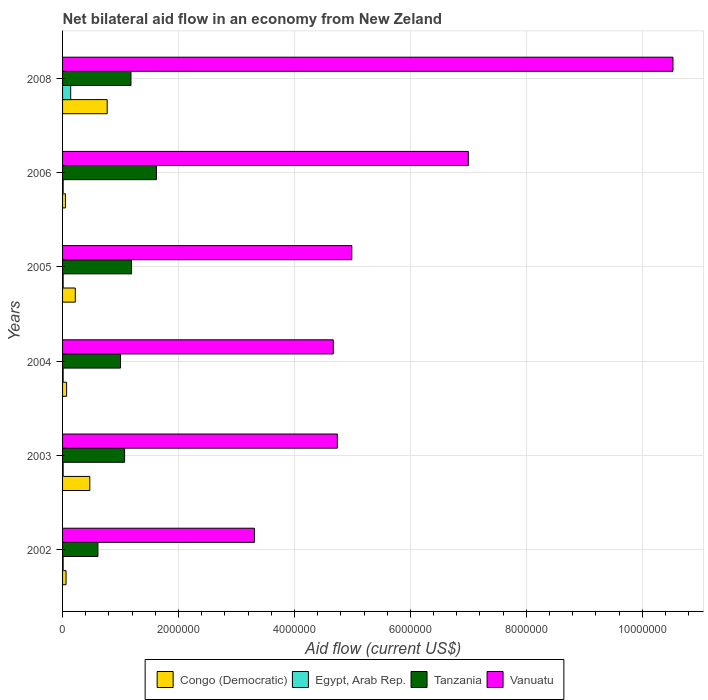How many different coloured bars are there?
Keep it short and to the point. 4. How many groups of bars are there?
Offer a very short reply. 6. Are the number of bars per tick equal to the number of legend labels?
Ensure brevity in your answer.  Yes. Are the number of bars on each tick of the Y-axis equal?
Ensure brevity in your answer.  Yes. How many bars are there on the 3rd tick from the top?
Make the answer very short. 4. How many bars are there on the 4th tick from the bottom?
Your answer should be very brief. 4. What is the label of the 4th group of bars from the top?
Offer a terse response. 2004. In how many cases, is the number of bars for a given year not equal to the number of legend labels?
Your answer should be very brief. 0. Across all years, what is the maximum net bilateral aid flow in Congo (Democratic)?
Your answer should be compact. 7.70e+05. Across all years, what is the minimum net bilateral aid flow in Congo (Democratic)?
Offer a very short reply. 5.00e+04. In which year was the net bilateral aid flow in Vanuatu maximum?
Your answer should be very brief. 2008. In which year was the net bilateral aid flow in Vanuatu minimum?
Give a very brief answer. 2002. What is the total net bilateral aid flow in Egypt, Arab Rep. in the graph?
Keep it short and to the point. 1.90e+05. What is the difference between the net bilateral aid flow in Congo (Democratic) in 2002 and that in 2005?
Provide a short and direct response. -1.60e+05. What is the difference between the net bilateral aid flow in Vanuatu in 2006 and the net bilateral aid flow in Congo (Democratic) in 2003?
Ensure brevity in your answer.  6.53e+06. What is the average net bilateral aid flow in Tanzania per year?
Make the answer very short. 1.11e+06. In the year 2008, what is the difference between the net bilateral aid flow in Vanuatu and net bilateral aid flow in Congo (Democratic)?
Provide a succinct answer. 9.76e+06. In how many years, is the net bilateral aid flow in Tanzania greater than 7600000 US$?
Your answer should be very brief. 0. What is the ratio of the net bilateral aid flow in Tanzania in 2002 to that in 2006?
Provide a short and direct response. 0.38. Is the difference between the net bilateral aid flow in Vanuatu in 2002 and 2004 greater than the difference between the net bilateral aid flow in Congo (Democratic) in 2002 and 2004?
Provide a succinct answer. No. What is the difference between the highest and the lowest net bilateral aid flow in Vanuatu?
Provide a succinct answer. 7.22e+06. In how many years, is the net bilateral aid flow in Congo (Democratic) greater than the average net bilateral aid flow in Congo (Democratic) taken over all years?
Offer a very short reply. 2. Is the sum of the net bilateral aid flow in Egypt, Arab Rep. in 2002 and 2008 greater than the maximum net bilateral aid flow in Vanuatu across all years?
Provide a succinct answer. No. Is it the case that in every year, the sum of the net bilateral aid flow in Congo (Democratic) and net bilateral aid flow in Egypt, Arab Rep. is greater than the sum of net bilateral aid flow in Tanzania and net bilateral aid flow in Vanuatu?
Provide a succinct answer. No. What does the 2nd bar from the top in 2008 represents?
Give a very brief answer. Tanzania. What does the 3rd bar from the bottom in 2003 represents?
Provide a short and direct response. Tanzania. How many years are there in the graph?
Provide a succinct answer. 6. Does the graph contain any zero values?
Offer a very short reply. No. Where does the legend appear in the graph?
Your response must be concise. Bottom center. What is the title of the graph?
Ensure brevity in your answer.  Net bilateral aid flow in an economy from New Zeland. Does "Libya" appear as one of the legend labels in the graph?
Offer a terse response. No. What is the label or title of the X-axis?
Provide a short and direct response. Aid flow (current US$). What is the label or title of the Y-axis?
Provide a short and direct response. Years. What is the Aid flow (current US$) of Congo (Democratic) in 2002?
Provide a succinct answer. 6.00e+04. What is the Aid flow (current US$) in Egypt, Arab Rep. in 2002?
Your response must be concise. 10000. What is the Aid flow (current US$) of Vanuatu in 2002?
Keep it short and to the point. 3.31e+06. What is the Aid flow (current US$) of Congo (Democratic) in 2003?
Offer a very short reply. 4.70e+05. What is the Aid flow (current US$) of Egypt, Arab Rep. in 2003?
Ensure brevity in your answer.  10000. What is the Aid flow (current US$) in Tanzania in 2003?
Your response must be concise. 1.07e+06. What is the Aid flow (current US$) in Vanuatu in 2003?
Keep it short and to the point. 4.74e+06. What is the Aid flow (current US$) in Congo (Democratic) in 2004?
Make the answer very short. 7.00e+04. What is the Aid flow (current US$) in Vanuatu in 2004?
Keep it short and to the point. 4.67e+06. What is the Aid flow (current US$) of Tanzania in 2005?
Give a very brief answer. 1.19e+06. What is the Aid flow (current US$) of Vanuatu in 2005?
Make the answer very short. 4.99e+06. What is the Aid flow (current US$) in Congo (Democratic) in 2006?
Ensure brevity in your answer.  5.00e+04. What is the Aid flow (current US$) of Egypt, Arab Rep. in 2006?
Your response must be concise. 10000. What is the Aid flow (current US$) in Tanzania in 2006?
Your response must be concise. 1.62e+06. What is the Aid flow (current US$) in Vanuatu in 2006?
Offer a very short reply. 7.00e+06. What is the Aid flow (current US$) of Congo (Democratic) in 2008?
Your answer should be very brief. 7.70e+05. What is the Aid flow (current US$) of Tanzania in 2008?
Give a very brief answer. 1.18e+06. What is the Aid flow (current US$) of Vanuatu in 2008?
Ensure brevity in your answer.  1.05e+07. Across all years, what is the maximum Aid flow (current US$) of Congo (Democratic)?
Offer a very short reply. 7.70e+05. Across all years, what is the maximum Aid flow (current US$) of Egypt, Arab Rep.?
Your answer should be compact. 1.40e+05. Across all years, what is the maximum Aid flow (current US$) of Tanzania?
Offer a very short reply. 1.62e+06. Across all years, what is the maximum Aid flow (current US$) of Vanuatu?
Provide a succinct answer. 1.05e+07. Across all years, what is the minimum Aid flow (current US$) in Egypt, Arab Rep.?
Your answer should be very brief. 10000. Across all years, what is the minimum Aid flow (current US$) of Vanuatu?
Keep it short and to the point. 3.31e+06. What is the total Aid flow (current US$) of Congo (Democratic) in the graph?
Offer a terse response. 1.64e+06. What is the total Aid flow (current US$) of Egypt, Arab Rep. in the graph?
Provide a short and direct response. 1.90e+05. What is the total Aid flow (current US$) of Tanzania in the graph?
Your answer should be very brief. 6.67e+06. What is the total Aid flow (current US$) of Vanuatu in the graph?
Your response must be concise. 3.52e+07. What is the difference between the Aid flow (current US$) of Congo (Democratic) in 2002 and that in 2003?
Your answer should be very brief. -4.10e+05. What is the difference between the Aid flow (current US$) in Egypt, Arab Rep. in 2002 and that in 2003?
Give a very brief answer. 0. What is the difference between the Aid flow (current US$) of Tanzania in 2002 and that in 2003?
Offer a terse response. -4.60e+05. What is the difference between the Aid flow (current US$) in Vanuatu in 2002 and that in 2003?
Give a very brief answer. -1.43e+06. What is the difference between the Aid flow (current US$) in Congo (Democratic) in 2002 and that in 2004?
Your response must be concise. -10000. What is the difference between the Aid flow (current US$) in Egypt, Arab Rep. in 2002 and that in 2004?
Ensure brevity in your answer.  0. What is the difference between the Aid flow (current US$) of Tanzania in 2002 and that in 2004?
Offer a terse response. -3.90e+05. What is the difference between the Aid flow (current US$) of Vanuatu in 2002 and that in 2004?
Provide a short and direct response. -1.36e+06. What is the difference between the Aid flow (current US$) of Tanzania in 2002 and that in 2005?
Your answer should be compact. -5.80e+05. What is the difference between the Aid flow (current US$) in Vanuatu in 2002 and that in 2005?
Provide a succinct answer. -1.68e+06. What is the difference between the Aid flow (current US$) of Egypt, Arab Rep. in 2002 and that in 2006?
Offer a terse response. 0. What is the difference between the Aid flow (current US$) in Tanzania in 2002 and that in 2006?
Keep it short and to the point. -1.01e+06. What is the difference between the Aid flow (current US$) of Vanuatu in 2002 and that in 2006?
Offer a very short reply. -3.69e+06. What is the difference between the Aid flow (current US$) of Congo (Democratic) in 2002 and that in 2008?
Give a very brief answer. -7.10e+05. What is the difference between the Aid flow (current US$) of Tanzania in 2002 and that in 2008?
Your response must be concise. -5.70e+05. What is the difference between the Aid flow (current US$) in Vanuatu in 2002 and that in 2008?
Ensure brevity in your answer.  -7.22e+06. What is the difference between the Aid flow (current US$) of Congo (Democratic) in 2003 and that in 2004?
Make the answer very short. 4.00e+05. What is the difference between the Aid flow (current US$) in Egypt, Arab Rep. in 2003 and that in 2004?
Keep it short and to the point. 0. What is the difference between the Aid flow (current US$) in Tanzania in 2003 and that in 2004?
Make the answer very short. 7.00e+04. What is the difference between the Aid flow (current US$) in Egypt, Arab Rep. in 2003 and that in 2005?
Your answer should be compact. 0. What is the difference between the Aid flow (current US$) in Tanzania in 2003 and that in 2005?
Provide a succinct answer. -1.20e+05. What is the difference between the Aid flow (current US$) in Egypt, Arab Rep. in 2003 and that in 2006?
Offer a terse response. 0. What is the difference between the Aid flow (current US$) in Tanzania in 2003 and that in 2006?
Keep it short and to the point. -5.50e+05. What is the difference between the Aid flow (current US$) in Vanuatu in 2003 and that in 2006?
Your response must be concise. -2.26e+06. What is the difference between the Aid flow (current US$) of Tanzania in 2003 and that in 2008?
Make the answer very short. -1.10e+05. What is the difference between the Aid flow (current US$) in Vanuatu in 2003 and that in 2008?
Keep it short and to the point. -5.79e+06. What is the difference between the Aid flow (current US$) in Congo (Democratic) in 2004 and that in 2005?
Offer a terse response. -1.50e+05. What is the difference between the Aid flow (current US$) of Vanuatu in 2004 and that in 2005?
Provide a succinct answer. -3.20e+05. What is the difference between the Aid flow (current US$) in Congo (Democratic) in 2004 and that in 2006?
Make the answer very short. 2.00e+04. What is the difference between the Aid flow (current US$) in Tanzania in 2004 and that in 2006?
Offer a very short reply. -6.20e+05. What is the difference between the Aid flow (current US$) of Vanuatu in 2004 and that in 2006?
Give a very brief answer. -2.33e+06. What is the difference between the Aid flow (current US$) in Congo (Democratic) in 2004 and that in 2008?
Offer a terse response. -7.00e+05. What is the difference between the Aid flow (current US$) of Tanzania in 2004 and that in 2008?
Offer a terse response. -1.80e+05. What is the difference between the Aid flow (current US$) in Vanuatu in 2004 and that in 2008?
Provide a succinct answer. -5.86e+06. What is the difference between the Aid flow (current US$) of Tanzania in 2005 and that in 2006?
Provide a short and direct response. -4.30e+05. What is the difference between the Aid flow (current US$) of Vanuatu in 2005 and that in 2006?
Offer a very short reply. -2.01e+06. What is the difference between the Aid flow (current US$) of Congo (Democratic) in 2005 and that in 2008?
Provide a short and direct response. -5.50e+05. What is the difference between the Aid flow (current US$) in Vanuatu in 2005 and that in 2008?
Provide a short and direct response. -5.54e+06. What is the difference between the Aid flow (current US$) in Congo (Democratic) in 2006 and that in 2008?
Ensure brevity in your answer.  -7.20e+05. What is the difference between the Aid flow (current US$) of Egypt, Arab Rep. in 2006 and that in 2008?
Offer a very short reply. -1.30e+05. What is the difference between the Aid flow (current US$) in Vanuatu in 2006 and that in 2008?
Make the answer very short. -3.53e+06. What is the difference between the Aid flow (current US$) in Congo (Democratic) in 2002 and the Aid flow (current US$) in Tanzania in 2003?
Your response must be concise. -1.01e+06. What is the difference between the Aid flow (current US$) in Congo (Democratic) in 2002 and the Aid flow (current US$) in Vanuatu in 2003?
Offer a terse response. -4.68e+06. What is the difference between the Aid flow (current US$) of Egypt, Arab Rep. in 2002 and the Aid flow (current US$) of Tanzania in 2003?
Offer a very short reply. -1.06e+06. What is the difference between the Aid flow (current US$) of Egypt, Arab Rep. in 2002 and the Aid flow (current US$) of Vanuatu in 2003?
Keep it short and to the point. -4.73e+06. What is the difference between the Aid flow (current US$) in Tanzania in 2002 and the Aid flow (current US$) in Vanuatu in 2003?
Offer a very short reply. -4.13e+06. What is the difference between the Aid flow (current US$) of Congo (Democratic) in 2002 and the Aid flow (current US$) of Egypt, Arab Rep. in 2004?
Provide a succinct answer. 5.00e+04. What is the difference between the Aid flow (current US$) of Congo (Democratic) in 2002 and the Aid flow (current US$) of Tanzania in 2004?
Your answer should be very brief. -9.40e+05. What is the difference between the Aid flow (current US$) of Congo (Democratic) in 2002 and the Aid flow (current US$) of Vanuatu in 2004?
Keep it short and to the point. -4.61e+06. What is the difference between the Aid flow (current US$) of Egypt, Arab Rep. in 2002 and the Aid flow (current US$) of Tanzania in 2004?
Keep it short and to the point. -9.90e+05. What is the difference between the Aid flow (current US$) of Egypt, Arab Rep. in 2002 and the Aid flow (current US$) of Vanuatu in 2004?
Offer a very short reply. -4.66e+06. What is the difference between the Aid flow (current US$) in Tanzania in 2002 and the Aid flow (current US$) in Vanuatu in 2004?
Provide a succinct answer. -4.06e+06. What is the difference between the Aid flow (current US$) in Congo (Democratic) in 2002 and the Aid flow (current US$) in Tanzania in 2005?
Keep it short and to the point. -1.13e+06. What is the difference between the Aid flow (current US$) in Congo (Democratic) in 2002 and the Aid flow (current US$) in Vanuatu in 2005?
Ensure brevity in your answer.  -4.93e+06. What is the difference between the Aid flow (current US$) in Egypt, Arab Rep. in 2002 and the Aid flow (current US$) in Tanzania in 2005?
Make the answer very short. -1.18e+06. What is the difference between the Aid flow (current US$) in Egypt, Arab Rep. in 2002 and the Aid flow (current US$) in Vanuatu in 2005?
Your answer should be very brief. -4.98e+06. What is the difference between the Aid flow (current US$) in Tanzania in 2002 and the Aid flow (current US$) in Vanuatu in 2005?
Your answer should be compact. -4.38e+06. What is the difference between the Aid flow (current US$) of Congo (Democratic) in 2002 and the Aid flow (current US$) of Tanzania in 2006?
Provide a short and direct response. -1.56e+06. What is the difference between the Aid flow (current US$) in Congo (Democratic) in 2002 and the Aid flow (current US$) in Vanuatu in 2006?
Offer a terse response. -6.94e+06. What is the difference between the Aid flow (current US$) in Egypt, Arab Rep. in 2002 and the Aid flow (current US$) in Tanzania in 2006?
Provide a short and direct response. -1.61e+06. What is the difference between the Aid flow (current US$) in Egypt, Arab Rep. in 2002 and the Aid flow (current US$) in Vanuatu in 2006?
Make the answer very short. -6.99e+06. What is the difference between the Aid flow (current US$) in Tanzania in 2002 and the Aid flow (current US$) in Vanuatu in 2006?
Provide a short and direct response. -6.39e+06. What is the difference between the Aid flow (current US$) of Congo (Democratic) in 2002 and the Aid flow (current US$) of Tanzania in 2008?
Your answer should be very brief. -1.12e+06. What is the difference between the Aid flow (current US$) of Congo (Democratic) in 2002 and the Aid flow (current US$) of Vanuatu in 2008?
Provide a succinct answer. -1.05e+07. What is the difference between the Aid flow (current US$) in Egypt, Arab Rep. in 2002 and the Aid flow (current US$) in Tanzania in 2008?
Make the answer very short. -1.17e+06. What is the difference between the Aid flow (current US$) of Egypt, Arab Rep. in 2002 and the Aid flow (current US$) of Vanuatu in 2008?
Keep it short and to the point. -1.05e+07. What is the difference between the Aid flow (current US$) of Tanzania in 2002 and the Aid flow (current US$) of Vanuatu in 2008?
Give a very brief answer. -9.92e+06. What is the difference between the Aid flow (current US$) of Congo (Democratic) in 2003 and the Aid flow (current US$) of Tanzania in 2004?
Provide a succinct answer. -5.30e+05. What is the difference between the Aid flow (current US$) of Congo (Democratic) in 2003 and the Aid flow (current US$) of Vanuatu in 2004?
Give a very brief answer. -4.20e+06. What is the difference between the Aid flow (current US$) of Egypt, Arab Rep. in 2003 and the Aid flow (current US$) of Tanzania in 2004?
Offer a terse response. -9.90e+05. What is the difference between the Aid flow (current US$) of Egypt, Arab Rep. in 2003 and the Aid flow (current US$) of Vanuatu in 2004?
Make the answer very short. -4.66e+06. What is the difference between the Aid flow (current US$) in Tanzania in 2003 and the Aid flow (current US$) in Vanuatu in 2004?
Offer a terse response. -3.60e+06. What is the difference between the Aid flow (current US$) of Congo (Democratic) in 2003 and the Aid flow (current US$) of Egypt, Arab Rep. in 2005?
Offer a terse response. 4.60e+05. What is the difference between the Aid flow (current US$) in Congo (Democratic) in 2003 and the Aid flow (current US$) in Tanzania in 2005?
Make the answer very short. -7.20e+05. What is the difference between the Aid flow (current US$) in Congo (Democratic) in 2003 and the Aid flow (current US$) in Vanuatu in 2005?
Offer a very short reply. -4.52e+06. What is the difference between the Aid flow (current US$) in Egypt, Arab Rep. in 2003 and the Aid flow (current US$) in Tanzania in 2005?
Keep it short and to the point. -1.18e+06. What is the difference between the Aid flow (current US$) in Egypt, Arab Rep. in 2003 and the Aid flow (current US$) in Vanuatu in 2005?
Keep it short and to the point. -4.98e+06. What is the difference between the Aid flow (current US$) of Tanzania in 2003 and the Aid flow (current US$) of Vanuatu in 2005?
Your answer should be compact. -3.92e+06. What is the difference between the Aid flow (current US$) in Congo (Democratic) in 2003 and the Aid flow (current US$) in Egypt, Arab Rep. in 2006?
Give a very brief answer. 4.60e+05. What is the difference between the Aid flow (current US$) of Congo (Democratic) in 2003 and the Aid flow (current US$) of Tanzania in 2006?
Your answer should be compact. -1.15e+06. What is the difference between the Aid flow (current US$) of Congo (Democratic) in 2003 and the Aid flow (current US$) of Vanuatu in 2006?
Offer a terse response. -6.53e+06. What is the difference between the Aid flow (current US$) in Egypt, Arab Rep. in 2003 and the Aid flow (current US$) in Tanzania in 2006?
Make the answer very short. -1.61e+06. What is the difference between the Aid flow (current US$) of Egypt, Arab Rep. in 2003 and the Aid flow (current US$) of Vanuatu in 2006?
Your answer should be very brief. -6.99e+06. What is the difference between the Aid flow (current US$) in Tanzania in 2003 and the Aid flow (current US$) in Vanuatu in 2006?
Ensure brevity in your answer.  -5.93e+06. What is the difference between the Aid flow (current US$) in Congo (Democratic) in 2003 and the Aid flow (current US$) in Tanzania in 2008?
Your response must be concise. -7.10e+05. What is the difference between the Aid flow (current US$) in Congo (Democratic) in 2003 and the Aid flow (current US$) in Vanuatu in 2008?
Offer a very short reply. -1.01e+07. What is the difference between the Aid flow (current US$) in Egypt, Arab Rep. in 2003 and the Aid flow (current US$) in Tanzania in 2008?
Your answer should be compact. -1.17e+06. What is the difference between the Aid flow (current US$) of Egypt, Arab Rep. in 2003 and the Aid flow (current US$) of Vanuatu in 2008?
Give a very brief answer. -1.05e+07. What is the difference between the Aid flow (current US$) in Tanzania in 2003 and the Aid flow (current US$) in Vanuatu in 2008?
Offer a terse response. -9.46e+06. What is the difference between the Aid flow (current US$) in Congo (Democratic) in 2004 and the Aid flow (current US$) in Tanzania in 2005?
Your response must be concise. -1.12e+06. What is the difference between the Aid flow (current US$) of Congo (Democratic) in 2004 and the Aid flow (current US$) of Vanuatu in 2005?
Make the answer very short. -4.92e+06. What is the difference between the Aid flow (current US$) in Egypt, Arab Rep. in 2004 and the Aid flow (current US$) in Tanzania in 2005?
Your answer should be compact. -1.18e+06. What is the difference between the Aid flow (current US$) in Egypt, Arab Rep. in 2004 and the Aid flow (current US$) in Vanuatu in 2005?
Offer a very short reply. -4.98e+06. What is the difference between the Aid flow (current US$) in Tanzania in 2004 and the Aid flow (current US$) in Vanuatu in 2005?
Provide a short and direct response. -3.99e+06. What is the difference between the Aid flow (current US$) in Congo (Democratic) in 2004 and the Aid flow (current US$) in Tanzania in 2006?
Your answer should be compact. -1.55e+06. What is the difference between the Aid flow (current US$) of Congo (Democratic) in 2004 and the Aid flow (current US$) of Vanuatu in 2006?
Provide a succinct answer. -6.93e+06. What is the difference between the Aid flow (current US$) of Egypt, Arab Rep. in 2004 and the Aid flow (current US$) of Tanzania in 2006?
Provide a short and direct response. -1.61e+06. What is the difference between the Aid flow (current US$) in Egypt, Arab Rep. in 2004 and the Aid flow (current US$) in Vanuatu in 2006?
Your response must be concise. -6.99e+06. What is the difference between the Aid flow (current US$) in Tanzania in 2004 and the Aid flow (current US$) in Vanuatu in 2006?
Keep it short and to the point. -6.00e+06. What is the difference between the Aid flow (current US$) of Congo (Democratic) in 2004 and the Aid flow (current US$) of Tanzania in 2008?
Offer a very short reply. -1.11e+06. What is the difference between the Aid flow (current US$) of Congo (Democratic) in 2004 and the Aid flow (current US$) of Vanuatu in 2008?
Provide a short and direct response. -1.05e+07. What is the difference between the Aid flow (current US$) in Egypt, Arab Rep. in 2004 and the Aid flow (current US$) in Tanzania in 2008?
Provide a short and direct response. -1.17e+06. What is the difference between the Aid flow (current US$) in Egypt, Arab Rep. in 2004 and the Aid flow (current US$) in Vanuatu in 2008?
Give a very brief answer. -1.05e+07. What is the difference between the Aid flow (current US$) in Tanzania in 2004 and the Aid flow (current US$) in Vanuatu in 2008?
Make the answer very short. -9.53e+06. What is the difference between the Aid flow (current US$) in Congo (Democratic) in 2005 and the Aid flow (current US$) in Tanzania in 2006?
Your answer should be compact. -1.40e+06. What is the difference between the Aid flow (current US$) in Congo (Democratic) in 2005 and the Aid flow (current US$) in Vanuatu in 2006?
Offer a terse response. -6.78e+06. What is the difference between the Aid flow (current US$) of Egypt, Arab Rep. in 2005 and the Aid flow (current US$) of Tanzania in 2006?
Your answer should be very brief. -1.61e+06. What is the difference between the Aid flow (current US$) in Egypt, Arab Rep. in 2005 and the Aid flow (current US$) in Vanuatu in 2006?
Keep it short and to the point. -6.99e+06. What is the difference between the Aid flow (current US$) in Tanzania in 2005 and the Aid flow (current US$) in Vanuatu in 2006?
Provide a succinct answer. -5.81e+06. What is the difference between the Aid flow (current US$) of Congo (Democratic) in 2005 and the Aid flow (current US$) of Tanzania in 2008?
Ensure brevity in your answer.  -9.60e+05. What is the difference between the Aid flow (current US$) of Congo (Democratic) in 2005 and the Aid flow (current US$) of Vanuatu in 2008?
Provide a short and direct response. -1.03e+07. What is the difference between the Aid flow (current US$) of Egypt, Arab Rep. in 2005 and the Aid flow (current US$) of Tanzania in 2008?
Give a very brief answer. -1.17e+06. What is the difference between the Aid flow (current US$) in Egypt, Arab Rep. in 2005 and the Aid flow (current US$) in Vanuatu in 2008?
Offer a very short reply. -1.05e+07. What is the difference between the Aid flow (current US$) in Tanzania in 2005 and the Aid flow (current US$) in Vanuatu in 2008?
Keep it short and to the point. -9.34e+06. What is the difference between the Aid flow (current US$) in Congo (Democratic) in 2006 and the Aid flow (current US$) in Tanzania in 2008?
Provide a succinct answer. -1.13e+06. What is the difference between the Aid flow (current US$) in Congo (Democratic) in 2006 and the Aid flow (current US$) in Vanuatu in 2008?
Make the answer very short. -1.05e+07. What is the difference between the Aid flow (current US$) in Egypt, Arab Rep. in 2006 and the Aid flow (current US$) in Tanzania in 2008?
Offer a terse response. -1.17e+06. What is the difference between the Aid flow (current US$) of Egypt, Arab Rep. in 2006 and the Aid flow (current US$) of Vanuatu in 2008?
Ensure brevity in your answer.  -1.05e+07. What is the difference between the Aid flow (current US$) of Tanzania in 2006 and the Aid flow (current US$) of Vanuatu in 2008?
Your answer should be compact. -8.91e+06. What is the average Aid flow (current US$) of Congo (Democratic) per year?
Provide a succinct answer. 2.73e+05. What is the average Aid flow (current US$) of Egypt, Arab Rep. per year?
Keep it short and to the point. 3.17e+04. What is the average Aid flow (current US$) of Tanzania per year?
Offer a terse response. 1.11e+06. What is the average Aid flow (current US$) in Vanuatu per year?
Your response must be concise. 5.87e+06. In the year 2002, what is the difference between the Aid flow (current US$) of Congo (Democratic) and Aid flow (current US$) of Egypt, Arab Rep.?
Keep it short and to the point. 5.00e+04. In the year 2002, what is the difference between the Aid flow (current US$) of Congo (Democratic) and Aid flow (current US$) of Tanzania?
Provide a short and direct response. -5.50e+05. In the year 2002, what is the difference between the Aid flow (current US$) of Congo (Democratic) and Aid flow (current US$) of Vanuatu?
Make the answer very short. -3.25e+06. In the year 2002, what is the difference between the Aid flow (current US$) in Egypt, Arab Rep. and Aid flow (current US$) in Tanzania?
Offer a terse response. -6.00e+05. In the year 2002, what is the difference between the Aid flow (current US$) of Egypt, Arab Rep. and Aid flow (current US$) of Vanuatu?
Provide a succinct answer. -3.30e+06. In the year 2002, what is the difference between the Aid flow (current US$) in Tanzania and Aid flow (current US$) in Vanuatu?
Ensure brevity in your answer.  -2.70e+06. In the year 2003, what is the difference between the Aid flow (current US$) of Congo (Democratic) and Aid flow (current US$) of Tanzania?
Provide a succinct answer. -6.00e+05. In the year 2003, what is the difference between the Aid flow (current US$) in Congo (Democratic) and Aid flow (current US$) in Vanuatu?
Offer a very short reply. -4.27e+06. In the year 2003, what is the difference between the Aid flow (current US$) of Egypt, Arab Rep. and Aid flow (current US$) of Tanzania?
Your answer should be compact. -1.06e+06. In the year 2003, what is the difference between the Aid flow (current US$) of Egypt, Arab Rep. and Aid flow (current US$) of Vanuatu?
Keep it short and to the point. -4.73e+06. In the year 2003, what is the difference between the Aid flow (current US$) in Tanzania and Aid flow (current US$) in Vanuatu?
Give a very brief answer. -3.67e+06. In the year 2004, what is the difference between the Aid flow (current US$) in Congo (Democratic) and Aid flow (current US$) in Egypt, Arab Rep.?
Keep it short and to the point. 6.00e+04. In the year 2004, what is the difference between the Aid flow (current US$) in Congo (Democratic) and Aid flow (current US$) in Tanzania?
Keep it short and to the point. -9.30e+05. In the year 2004, what is the difference between the Aid flow (current US$) of Congo (Democratic) and Aid flow (current US$) of Vanuatu?
Keep it short and to the point. -4.60e+06. In the year 2004, what is the difference between the Aid flow (current US$) of Egypt, Arab Rep. and Aid flow (current US$) of Tanzania?
Ensure brevity in your answer.  -9.90e+05. In the year 2004, what is the difference between the Aid flow (current US$) of Egypt, Arab Rep. and Aid flow (current US$) of Vanuatu?
Give a very brief answer. -4.66e+06. In the year 2004, what is the difference between the Aid flow (current US$) of Tanzania and Aid flow (current US$) of Vanuatu?
Provide a succinct answer. -3.67e+06. In the year 2005, what is the difference between the Aid flow (current US$) in Congo (Democratic) and Aid flow (current US$) in Tanzania?
Give a very brief answer. -9.70e+05. In the year 2005, what is the difference between the Aid flow (current US$) in Congo (Democratic) and Aid flow (current US$) in Vanuatu?
Your answer should be very brief. -4.77e+06. In the year 2005, what is the difference between the Aid flow (current US$) of Egypt, Arab Rep. and Aid flow (current US$) of Tanzania?
Give a very brief answer. -1.18e+06. In the year 2005, what is the difference between the Aid flow (current US$) in Egypt, Arab Rep. and Aid flow (current US$) in Vanuatu?
Give a very brief answer. -4.98e+06. In the year 2005, what is the difference between the Aid flow (current US$) of Tanzania and Aid flow (current US$) of Vanuatu?
Your response must be concise. -3.80e+06. In the year 2006, what is the difference between the Aid flow (current US$) in Congo (Democratic) and Aid flow (current US$) in Egypt, Arab Rep.?
Provide a succinct answer. 4.00e+04. In the year 2006, what is the difference between the Aid flow (current US$) in Congo (Democratic) and Aid flow (current US$) in Tanzania?
Your answer should be very brief. -1.57e+06. In the year 2006, what is the difference between the Aid flow (current US$) in Congo (Democratic) and Aid flow (current US$) in Vanuatu?
Give a very brief answer. -6.95e+06. In the year 2006, what is the difference between the Aid flow (current US$) in Egypt, Arab Rep. and Aid flow (current US$) in Tanzania?
Your answer should be compact. -1.61e+06. In the year 2006, what is the difference between the Aid flow (current US$) of Egypt, Arab Rep. and Aid flow (current US$) of Vanuatu?
Your response must be concise. -6.99e+06. In the year 2006, what is the difference between the Aid flow (current US$) in Tanzania and Aid flow (current US$) in Vanuatu?
Provide a succinct answer. -5.38e+06. In the year 2008, what is the difference between the Aid flow (current US$) in Congo (Democratic) and Aid flow (current US$) in Egypt, Arab Rep.?
Give a very brief answer. 6.30e+05. In the year 2008, what is the difference between the Aid flow (current US$) of Congo (Democratic) and Aid flow (current US$) of Tanzania?
Offer a terse response. -4.10e+05. In the year 2008, what is the difference between the Aid flow (current US$) of Congo (Democratic) and Aid flow (current US$) of Vanuatu?
Provide a short and direct response. -9.76e+06. In the year 2008, what is the difference between the Aid flow (current US$) in Egypt, Arab Rep. and Aid flow (current US$) in Tanzania?
Give a very brief answer. -1.04e+06. In the year 2008, what is the difference between the Aid flow (current US$) of Egypt, Arab Rep. and Aid flow (current US$) of Vanuatu?
Your answer should be very brief. -1.04e+07. In the year 2008, what is the difference between the Aid flow (current US$) of Tanzania and Aid flow (current US$) of Vanuatu?
Make the answer very short. -9.35e+06. What is the ratio of the Aid flow (current US$) in Congo (Democratic) in 2002 to that in 2003?
Your answer should be compact. 0.13. What is the ratio of the Aid flow (current US$) in Egypt, Arab Rep. in 2002 to that in 2003?
Your answer should be compact. 1. What is the ratio of the Aid flow (current US$) in Tanzania in 2002 to that in 2003?
Keep it short and to the point. 0.57. What is the ratio of the Aid flow (current US$) of Vanuatu in 2002 to that in 2003?
Provide a succinct answer. 0.7. What is the ratio of the Aid flow (current US$) in Congo (Democratic) in 2002 to that in 2004?
Provide a succinct answer. 0.86. What is the ratio of the Aid flow (current US$) of Egypt, Arab Rep. in 2002 to that in 2004?
Your response must be concise. 1. What is the ratio of the Aid flow (current US$) in Tanzania in 2002 to that in 2004?
Offer a very short reply. 0.61. What is the ratio of the Aid flow (current US$) of Vanuatu in 2002 to that in 2004?
Provide a succinct answer. 0.71. What is the ratio of the Aid flow (current US$) in Congo (Democratic) in 2002 to that in 2005?
Offer a very short reply. 0.27. What is the ratio of the Aid flow (current US$) of Egypt, Arab Rep. in 2002 to that in 2005?
Your response must be concise. 1. What is the ratio of the Aid flow (current US$) of Tanzania in 2002 to that in 2005?
Keep it short and to the point. 0.51. What is the ratio of the Aid flow (current US$) in Vanuatu in 2002 to that in 2005?
Your answer should be very brief. 0.66. What is the ratio of the Aid flow (current US$) in Tanzania in 2002 to that in 2006?
Your response must be concise. 0.38. What is the ratio of the Aid flow (current US$) of Vanuatu in 2002 to that in 2006?
Provide a short and direct response. 0.47. What is the ratio of the Aid flow (current US$) in Congo (Democratic) in 2002 to that in 2008?
Give a very brief answer. 0.08. What is the ratio of the Aid flow (current US$) of Egypt, Arab Rep. in 2002 to that in 2008?
Your response must be concise. 0.07. What is the ratio of the Aid flow (current US$) of Tanzania in 2002 to that in 2008?
Ensure brevity in your answer.  0.52. What is the ratio of the Aid flow (current US$) of Vanuatu in 2002 to that in 2008?
Offer a terse response. 0.31. What is the ratio of the Aid flow (current US$) of Congo (Democratic) in 2003 to that in 2004?
Your response must be concise. 6.71. What is the ratio of the Aid flow (current US$) in Egypt, Arab Rep. in 2003 to that in 2004?
Provide a short and direct response. 1. What is the ratio of the Aid flow (current US$) in Tanzania in 2003 to that in 2004?
Make the answer very short. 1.07. What is the ratio of the Aid flow (current US$) in Vanuatu in 2003 to that in 2004?
Keep it short and to the point. 1.01. What is the ratio of the Aid flow (current US$) of Congo (Democratic) in 2003 to that in 2005?
Provide a succinct answer. 2.14. What is the ratio of the Aid flow (current US$) of Egypt, Arab Rep. in 2003 to that in 2005?
Your answer should be very brief. 1. What is the ratio of the Aid flow (current US$) in Tanzania in 2003 to that in 2005?
Offer a terse response. 0.9. What is the ratio of the Aid flow (current US$) of Vanuatu in 2003 to that in 2005?
Provide a short and direct response. 0.95. What is the ratio of the Aid flow (current US$) in Tanzania in 2003 to that in 2006?
Make the answer very short. 0.66. What is the ratio of the Aid flow (current US$) in Vanuatu in 2003 to that in 2006?
Provide a succinct answer. 0.68. What is the ratio of the Aid flow (current US$) of Congo (Democratic) in 2003 to that in 2008?
Your answer should be compact. 0.61. What is the ratio of the Aid flow (current US$) in Egypt, Arab Rep. in 2003 to that in 2008?
Offer a terse response. 0.07. What is the ratio of the Aid flow (current US$) in Tanzania in 2003 to that in 2008?
Give a very brief answer. 0.91. What is the ratio of the Aid flow (current US$) of Vanuatu in 2003 to that in 2008?
Your answer should be very brief. 0.45. What is the ratio of the Aid flow (current US$) of Congo (Democratic) in 2004 to that in 2005?
Provide a succinct answer. 0.32. What is the ratio of the Aid flow (current US$) in Egypt, Arab Rep. in 2004 to that in 2005?
Provide a succinct answer. 1. What is the ratio of the Aid flow (current US$) in Tanzania in 2004 to that in 2005?
Your answer should be very brief. 0.84. What is the ratio of the Aid flow (current US$) of Vanuatu in 2004 to that in 2005?
Offer a very short reply. 0.94. What is the ratio of the Aid flow (current US$) of Egypt, Arab Rep. in 2004 to that in 2006?
Your answer should be compact. 1. What is the ratio of the Aid flow (current US$) of Tanzania in 2004 to that in 2006?
Provide a short and direct response. 0.62. What is the ratio of the Aid flow (current US$) of Vanuatu in 2004 to that in 2006?
Provide a succinct answer. 0.67. What is the ratio of the Aid flow (current US$) of Congo (Democratic) in 2004 to that in 2008?
Offer a terse response. 0.09. What is the ratio of the Aid flow (current US$) in Egypt, Arab Rep. in 2004 to that in 2008?
Your answer should be very brief. 0.07. What is the ratio of the Aid flow (current US$) in Tanzania in 2004 to that in 2008?
Your answer should be compact. 0.85. What is the ratio of the Aid flow (current US$) in Vanuatu in 2004 to that in 2008?
Your answer should be compact. 0.44. What is the ratio of the Aid flow (current US$) in Egypt, Arab Rep. in 2005 to that in 2006?
Your answer should be compact. 1. What is the ratio of the Aid flow (current US$) of Tanzania in 2005 to that in 2006?
Provide a short and direct response. 0.73. What is the ratio of the Aid flow (current US$) of Vanuatu in 2005 to that in 2006?
Ensure brevity in your answer.  0.71. What is the ratio of the Aid flow (current US$) of Congo (Democratic) in 2005 to that in 2008?
Offer a terse response. 0.29. What is the ratio of the Aid flow (current US$) in Egypt, Arab Rep. in 2005 to that in 2008?
Your answer should be very brief. 0.07. What is the ratio of the Aid flow (current US$) of Tanzania in 2005 to that in 2008?
Your answer should be very brief. 1.01. What is the ratio of the Aid flow (current US$) in Vanuatu in 2005 to that in 2008?
Keep it short and to the point. 0.47. What is the ratio of the Aid flow (current US$) in Congo (Democratic) in 2006 to that in 2008?
Provide a succinct answer. 0.06. What is the ratio of the Aid flow (current US$) of Egypt, Arab Rep. in 2006 to that in 2008?
Your response must be concise. 0.07. What is the ratio of the Aid flow (current US$) of Tanzania in 2006 to that in 2008?
Offer a terse response. 1.37. What is the ratio of the Aid flow (current US$) of Vanuatu in 2006 to that in 2008?
Keep it short and to the point. 0.66. What is the difference between the highest and the second highest Aid flow (current US$) in Tanzania?
Offer a terse response. 4.30e+05. What is the difference between the highest and the second highest Aid flow (current US$) in Vanuatu?
Your answer should be very brief. 3.53e+06. What is the difference between the highest and the lowest Aid flow (current US$) of Congo (Democratic)?
Offer a very short reply. 7.20e+05. What is the difference between the highest and the lowest Aid flow (current US$) in Tanzania?
Your answer should be very brief. 1.01e+06. What is the difference between the highest and the lowest Aid flow (current US$) of Vanuatu?
Give a very brief answer. 7.22e+06. 